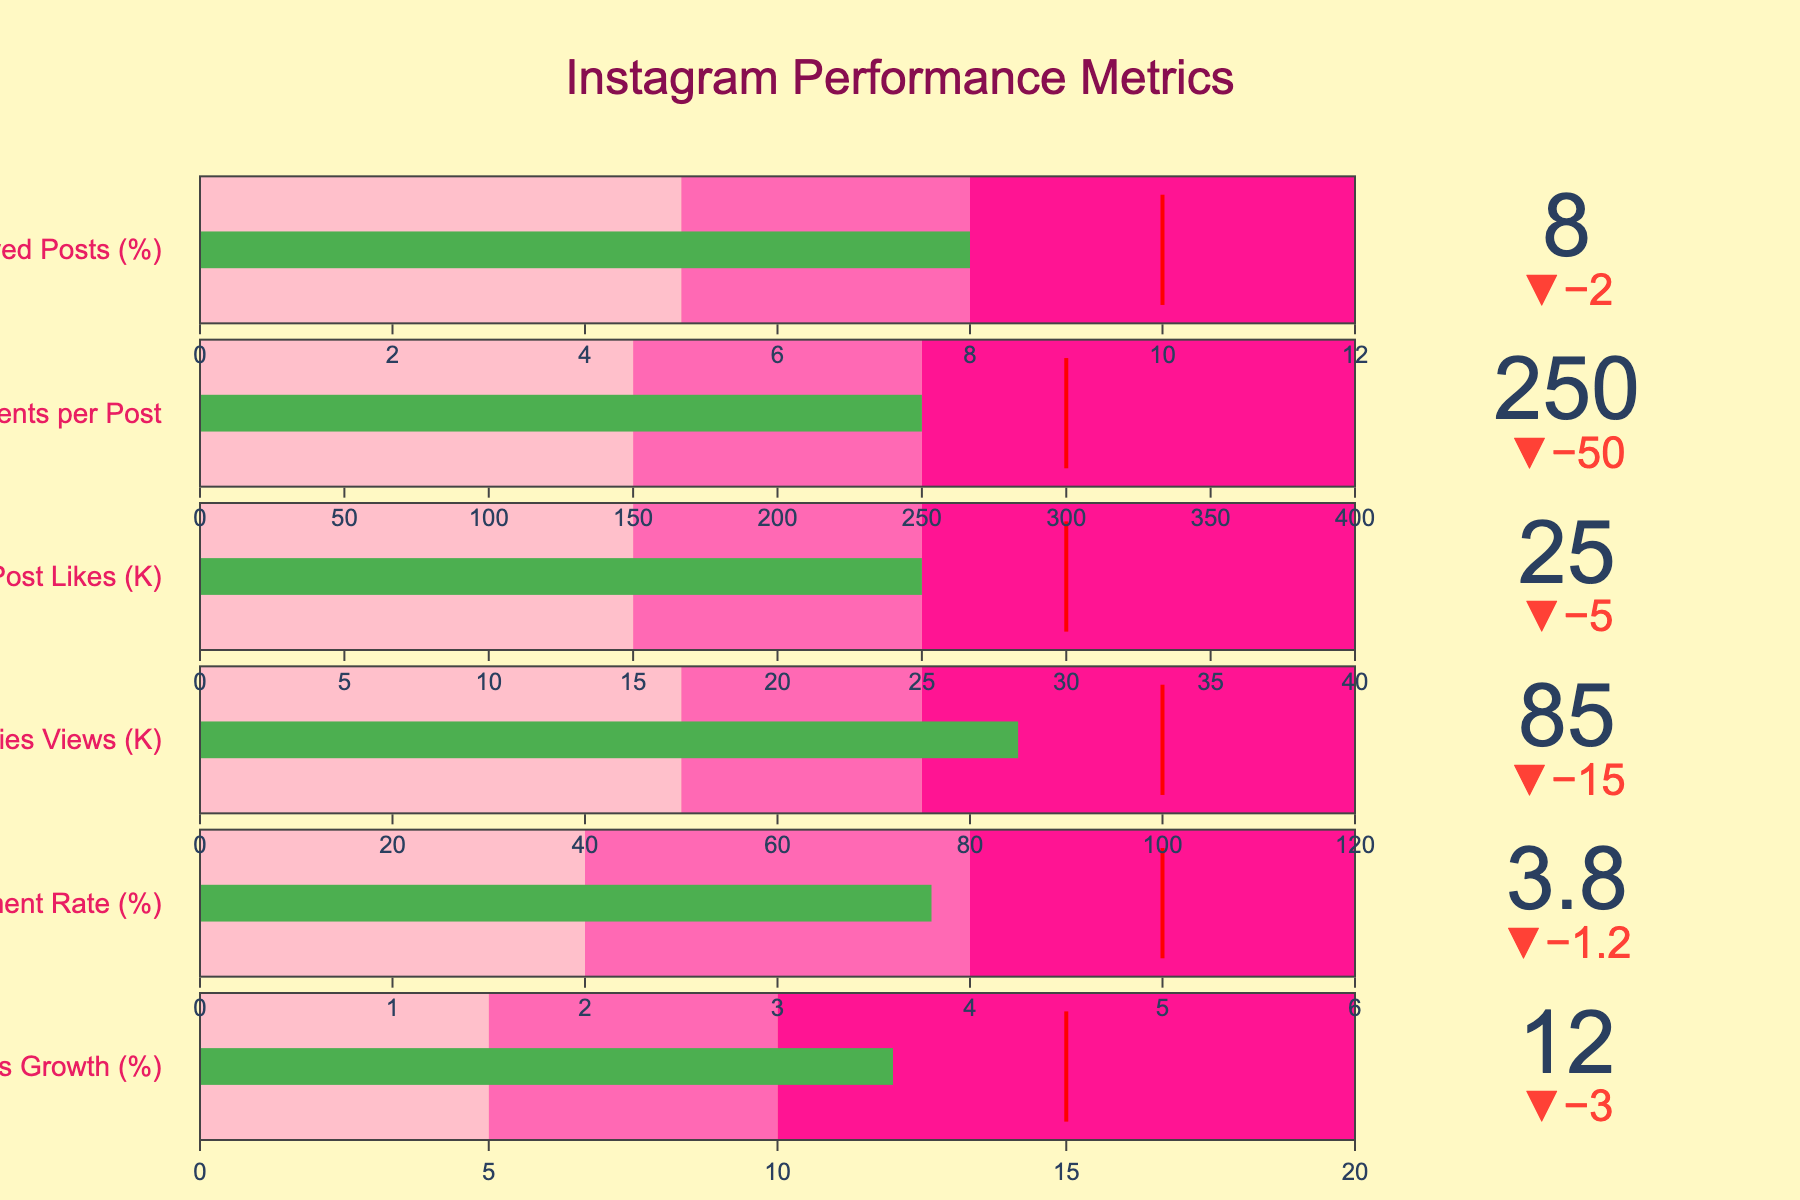What is the overall title of the figure? The title is displayed prominently at the top center of the figure.
Answer: Instagram Performance Metrics What is the actual value for Followers Growth (%)? The figure displays the actual value for Followers Growth (%) as 12%. This value can be found next to the first bullet chart.
Answer: 12% Is the Engagement Rate (%) above or below the target? The Engagement Rate (%) is at 3.8%, whereas the target is 5%. Since 3.8% is less than 5%, it is below the target.
Answer: Below How does the value of Stories Views (K) compare to its target? The value of Stories Views (K) is 85K and the target is 100K. Comparing these, 85K is less than 100K, indicating it is below the target.
Answer: Below the target What is the difference between the target and actual value in Comments per Post? The target for Comments per Post is 300, and the actual value is 250. The difference can be calculated by subtracting the actual from the target: 300 - 250.
Answer: 50 Which metric has the smallest difference from its target value? By observing the figure, calculating the absolute differences: Followers Growth (3), Engagement Rate (1.2), Stories Views (15), Post Likes (5), Comments per Post (50), and Saved Posts (2). The smallest difference is for Engagement Rate (1.2).
Answer: Engagement Rate (%) What range does the actual value for Post Likes (K) fall into? The actual value for Post Likes (K) is 25K. The ranges are defined as 15K-25K (second range). Since 25K is exactly on the threshold of the second range, it falls within the second range.
Answer: Second range (15-25K) What metric exceeds the second range but does not meet the target? Comparing the actual values against the second range and targets, we find that Stories Views (K) with an actual value of 85K fall in the range of 75K-120K but do not meet their target of 100K.
Answer: Stories Views (K) By how much does the actual value for Saved Posts (%) fall short of the target? The target for Saved Posts (%) is 10%, and the actual value is 8%. To find how much it falls short, subtract the actual value from the target: 10% - 8% = 2%.
Answer: 2% Which metric is performing the best against its target? By comparing all metrics, the smallest delta and closest to target is Comments per Post with a value of 250 against a target of 300. This falls into the best relative performance criteria.
Answer: Comments per Post 